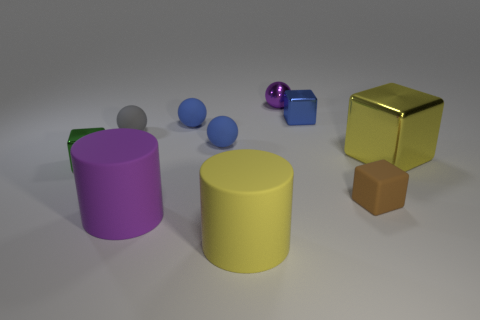What is the texture of the objects, and do any of them stand out in terms of material? The objects appear to have varying textures, with some boasting a shiny metallic finish, like the small blue cube and the purple sphere, while others have a more matte surface. The gold cube, in particular, stands out due to its highly reflective, glossy gold surface. 